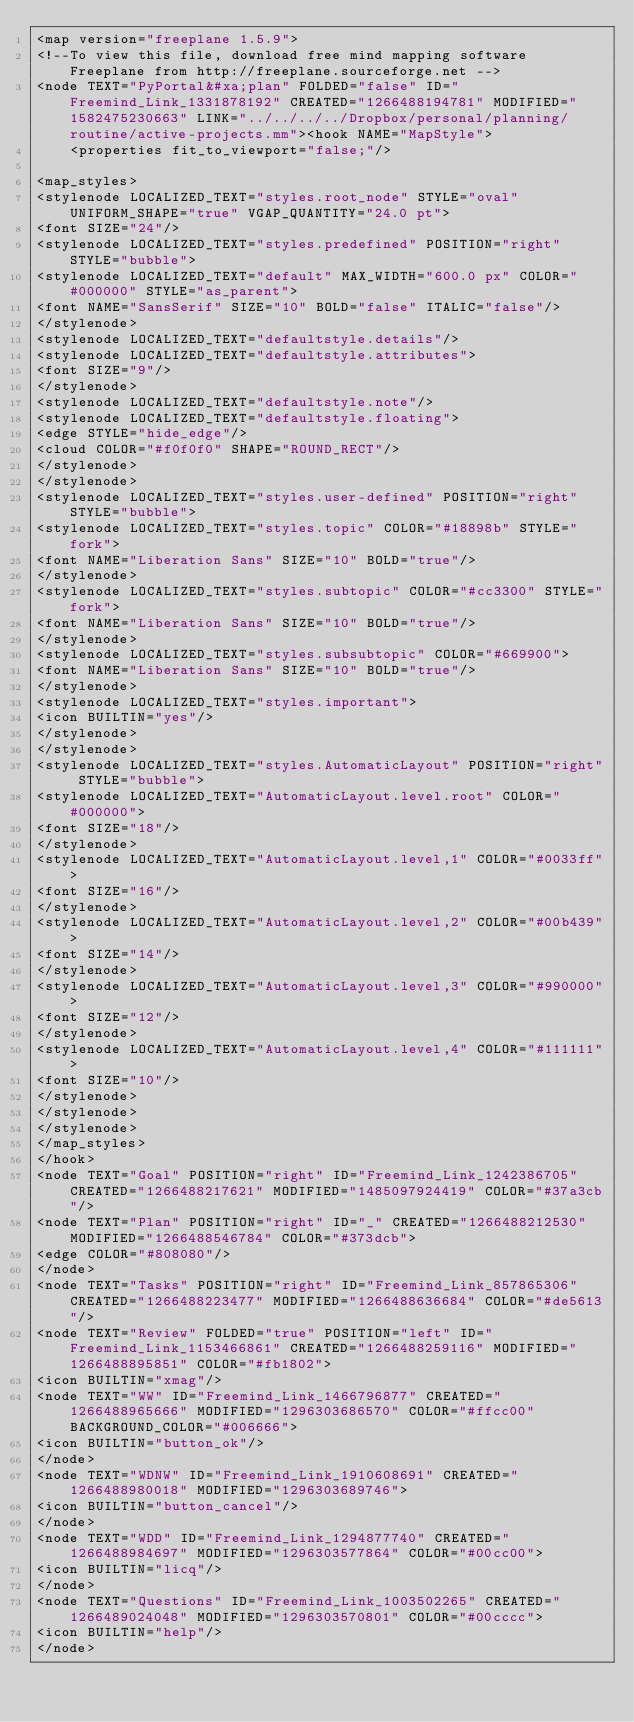<code> <loc_0><loc_0><loc_500><loc_500><_ObjectiveC_><map version="freeplane 1.5.9">
<!--To view this file, download free mind mapping software Freeplane from http://freeplane.sourceforge.net -->
<node TEXT="PyPortal&#xa;plan" FOLDED="false" ID="Freemind_Link_1331878192" CREATED="1266488194781" MODIFIED="1582475230663" LINK="../../../../Dropbox/personal/planning/routine/active-projects.mm"><hook NAME="MapStyle">
    <properties fit_to_viewport="false;"/>

<map_styles>
<stylenode LOCALIZED_TEXT="styles.root_node" STYLE="oval" UNIFORM_SHAPE="true" VGAP_QUANTITY="24.0 pt">
<font SIZE="24"/>
<stylenode LOCALIZED_TEXT="styles.predefined" POSITION="right" STYLE="bubble">
<stylenode LOCALIZED_TEXT="default" MAX_WIDTH="600.0 px" COLOR="#000000" STYLE="as_parent">
<font NAME="SansSerif" SIZE="10" BOLD="false" ITALIC="false"/>
</stylenode>
<stylenode LOCALIZED_TEXT="defaultstyle.details"/>
<stylenode LOCALIZED_TEXT="defaultstyle.attributes">
<font SIZE="9"/>
</stylenode>
<stylenode LOCALIZED_TEXT="defaultstyle.note"/>
<stylenode LOCALIZED_TEXT="defaultstyle.floating">
<edge STYLE="hide_edge"/>
<cloud COLOR="#f0f0f0" SHAPE="ROUND_RECT"/>
</stylenode>
</stylenode>
<stylenode LOCALIZED_TEXT="styles.user-defined" POSITION="right" STYLE="bubble">
<stylenode LOCALIZED_TEXT="styles.topic" COLOR="#18898b" STYLE="fork">
<font NAME="Liberation Sans" SIZE="10" BOLD="true"/>
</stylenode>
<stylenode LOCALIZED_TEXT="styles.subtopic" COLOR="#cc3300" STYLE="fork">
<font NAME="Liberation Sans" SIZE="10" BOLD="true"/>
</stylenode>
<stylenode LOCALIZED_TEXT="styles.subsubtopic" COLOR="#669900">
<font NAME="Liberation Sans" SIZE="10" BOLD="true"/>
</stylenode>
<stylenode LOCALIZED_TEXT="styles.important">
<icon BUILTIN="yes"/>
</stylenode>
</stylenode>
<stylenode LOCALIZED_TEXT="styles.AutomaticLayout" POSITION="right" STYLE="bubble">
<stylenode LOCALIZED_TEXT="AutomaticLayout.level.root" COLOR="#000000">
<font SIZE="18"/>
</stylenode>
<stylenode LOCALIZED_TEXT="AutomaticLayout.level,1" COLOR="#0033ff">
<font SIZE="16"/>
</stylenode>
<stylenode LOCALIZED_TEXT="AutomaticLayout.level,2" COLOR="#00b439">
<font SIZE="14"/>
</stylenode>
<stylenode LOCALIZED_TEXT="AutomaticLayout.level,3" COLOR="#990000">
<font SIZE="12"/>
</stylenode>
<stylenode LOCALIZED_TEXT="AutomaticLayout.level,4" COLOR="#111111">
<font SIZE="10"/>
</stylenode>
</stylenode>
</stylenode>
</map_styles>
</hook>
<node TEXT="Goal" POSITION="right" ID="Freemind_Link_1242386705" CREATED="1266488217621" MODIFIED="1485097924419" COLOR="#37a3cb"/>
<node TEXT="Plan" POSITION="right" ID="_" CREATED="1266488212530" MODIFIED="1266488546784" COLOR="#373dcb">
<edge COLOR="#808080"/>
</node>
<node TEXT="Tasks" POSITION="right" ID="Freemind_Link_857865306" CREATED="1266488223477" MODIFIED="1266488636684" COLOR="#de5613"/>
<node TEXT="Review" FOLDED="true" POSITION="left" ID="Freemind_Link_1153466861" CREATED="1266488259116" MODIFIED="1266488895851" COLOR="#fb1802">
<icon BUILTIN="xmag"/>
<node TEXT="WW" ID="Freemind_Link_1466796877" CREATED="1266488965666" MODIFIED="1296303686570" COLOR="#ffcc00" BACKGROUND_COLOR="#006666">
<icon BUILTIN="button_ok"/>
</node>
<node TEXT="WDNW" ID="Freemind_Link_1910608691" CREATED="1266488980018" MODIFIED="1296303689746">
<icon BUILTIN="button_cancel"/>
</node>
<node TEXT="WDD" ID="Freemind_Link_1294877740" CREATED="1266488984697" MODIFIED="1296303577864" COLOR="#00cc00">
<icon BUILTIN="licq"/>
</node>
<node TEXT="Questions" ID="Freemind_Link_1003502265" CREATED="1266489024048" MODIFIED="1296303570801" COLOR="#00cccc">
<icon BUILTIN="help"/>
</node></code> 